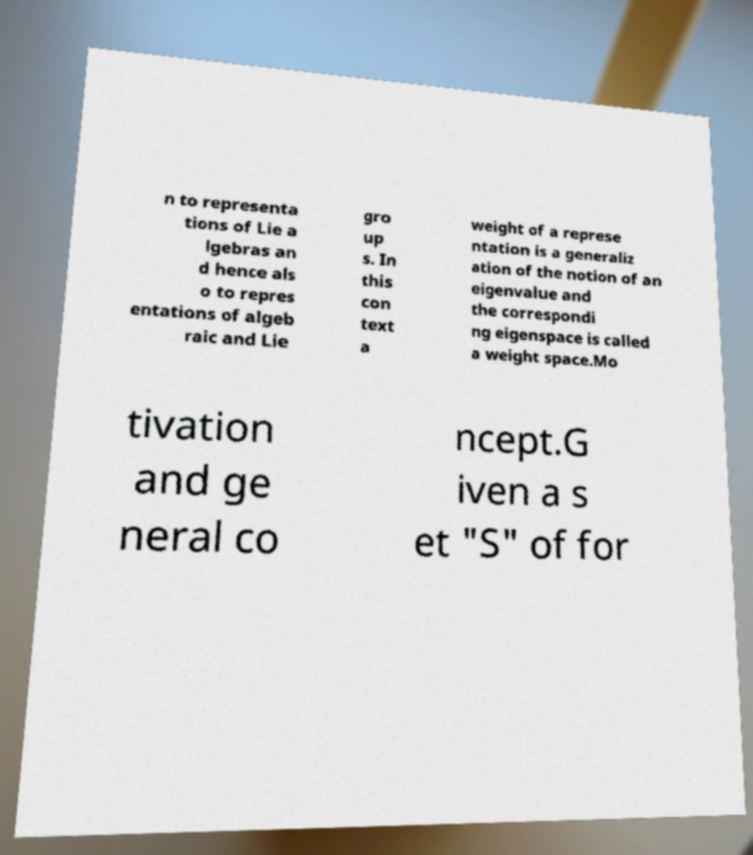Please identify and transcribe the text found in this image. n to representa tions of Lie a lgebras an d hence als o to repres entations of algeb raic and Lie gro up s. In this con text a weight of a represe ntation is a generaliz ation of the notion of an eigenvalue and the correspondi ng eigenspace is called a weight space.Mo tivation and ge neral co ncept.G iven a s et "S" of for 